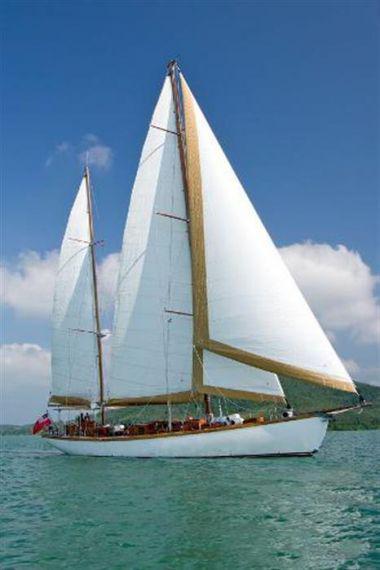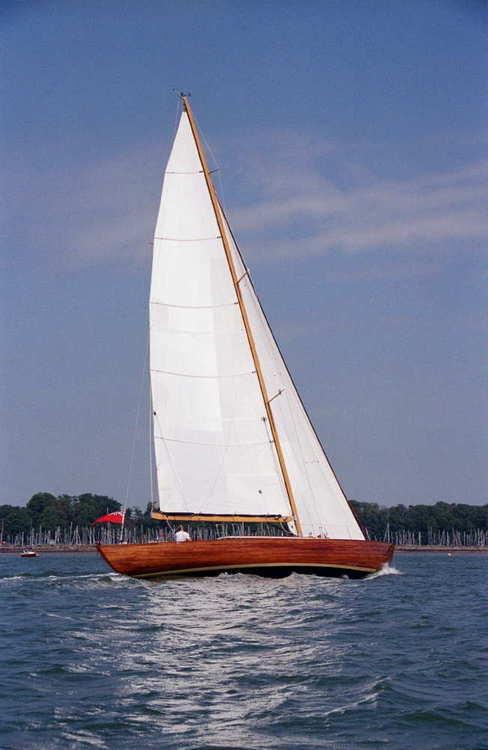The first image is the image on the left, the second image is the image on the right. Considering the images on both sides, is "A landform sits in the distance behind the boat in the image on the left." valid? Answer yes or no. Yes. 